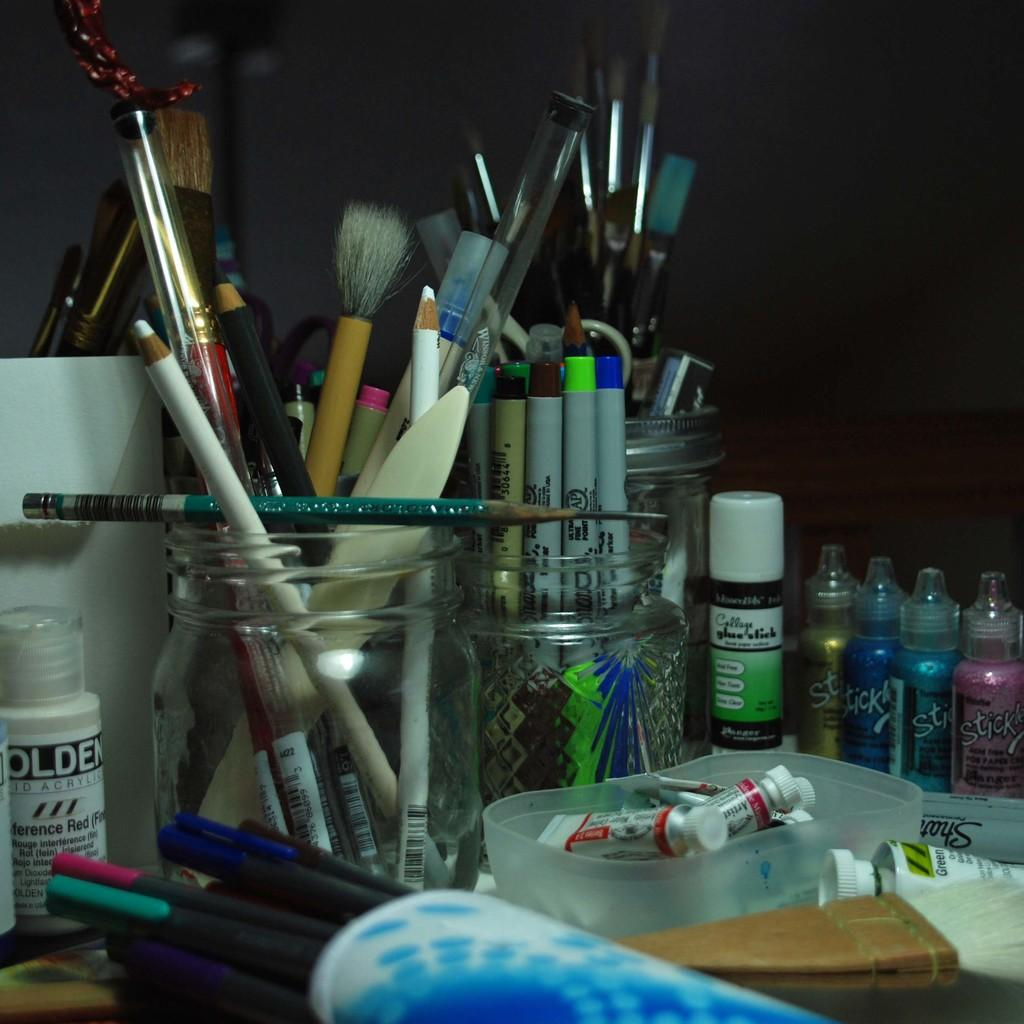Provide a one-sentence caption for the provided image. Various art supplies are on a table or in glass jars, including a Collage glue stick. 